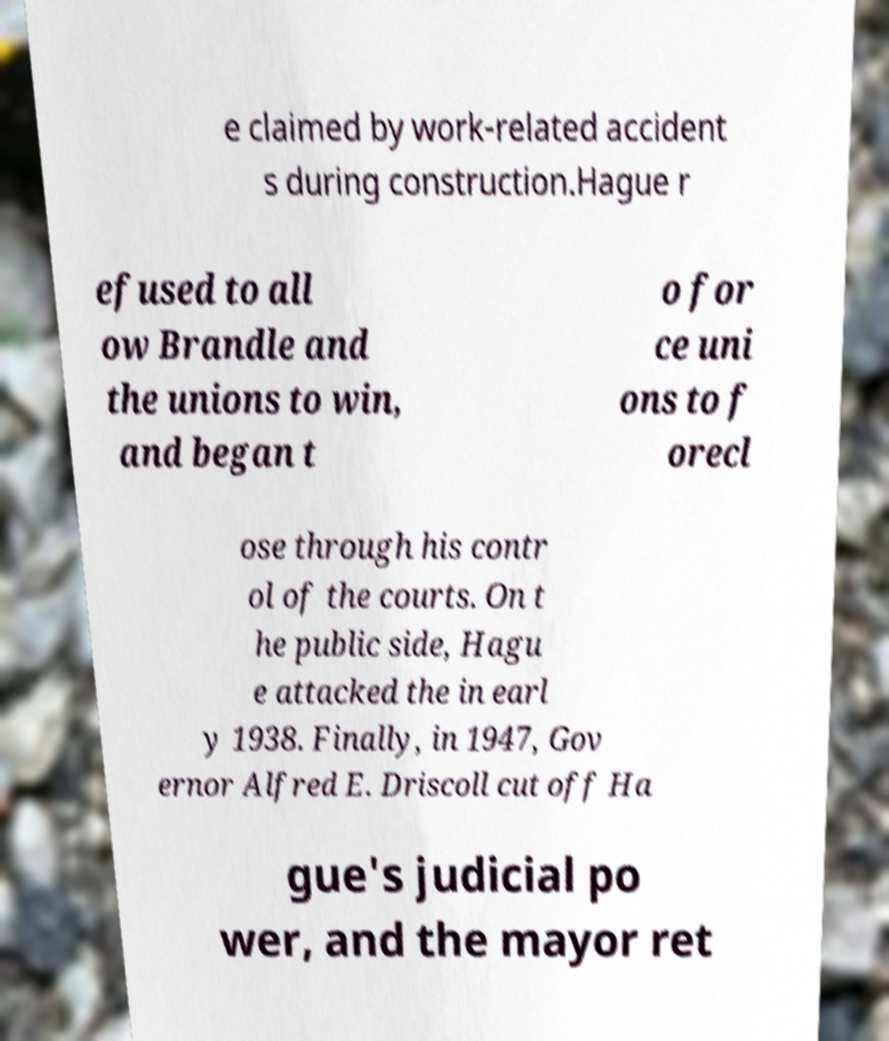Could you assist in decoding the text presented in this image and type it out clearly? e claimed by work-related accident s during construction.Hague r efused to all ow Brandle and the unions to win, and began t o for ce uni ons to f orecl ose through his contr ol of the courts. On t he public side, Hagu e attacked the in earl y 1938. Finally, in 1947, Gov ernor Alfred E. Driscoll cut off Ha gue's judicial po wer, and the mayor ret 